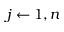<formula> <loc_0><loc_0><loc_500><loc_500>j \leftarrow 1 , n</formula> 